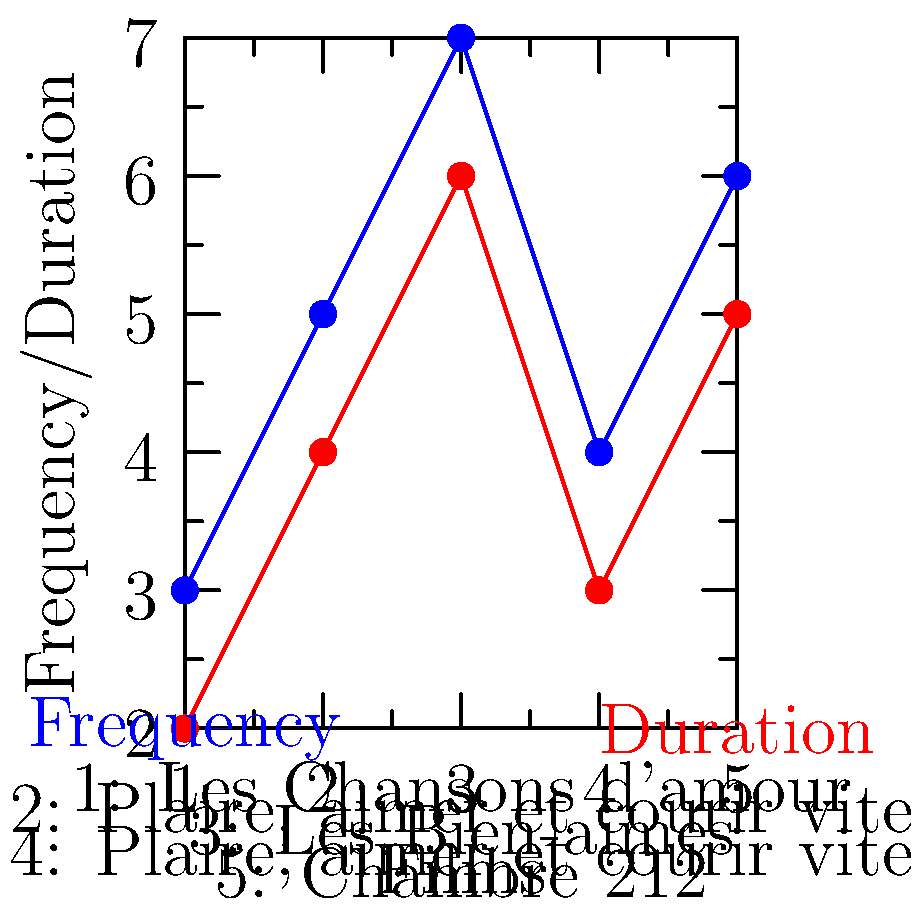Based on the graph depicting the frequency and duration of musical sequences in Christophe Honoré's films, which work appears to have the most significant musical presence, and how does this align with the director's known style and themes? To answer this question, we need to analyze the graph and consider Honoré's filmography:

1. Examine the graph:
   - Blue line represents frequency of musical sequences
   - Red line represents duration of musical sequences
   - X-axis shows five of Honoré's films
   - Y-axis indicates the frequency and duration values

2. Identify the film with the highest values:
   - Film 3 ("Les Bien-aimés") has the highest points for both frequency (7) and duration (6)

3. Consider Honoré's style and themes:
   - Known for incorporating music into his narratives
   - Often explores themes of love, sexuality, and personal identity
   - "Les Bien-aimés" (2011) is actually a musical drama

4. Analyze the alignment:
   - "Les Bien-aimés" being a musical drama explains its prominence in the graph
   - The high frequency and duration of musical sequences align with Honoré's tendency to use music as a storytelling device
   - This film represents a culmination of Honoré's interest in merging cinema and music

5. Compare to other films:
   - "Les Chansons d'amour" (Film 1) also has a significant musical presence, which is expected as it's another musical drama by Honoré
   - Other films show varying degrees of musical integration, reflecting Honoré's consistent but varied use of music across his filmography

The graph thus confirms that "Les Bien-aimés" has the most significant musical presence, aligning perfectly with Honoré's known style of integrating music into his narratives and his exploration of themes through musical elements.
Answer: "Les Bien-aimés", aligning with Honoré's musical narrative style 